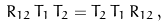Convert formula to latex. <formula><loc_0><loc_0><loc_500><loc_500>R _ { 1 2 } \, T _ { 1 } \, T _ { 2 } = T _ { 2 } \, T _ { 1 } \, R _ { 1 2 } \, ,</formula> 